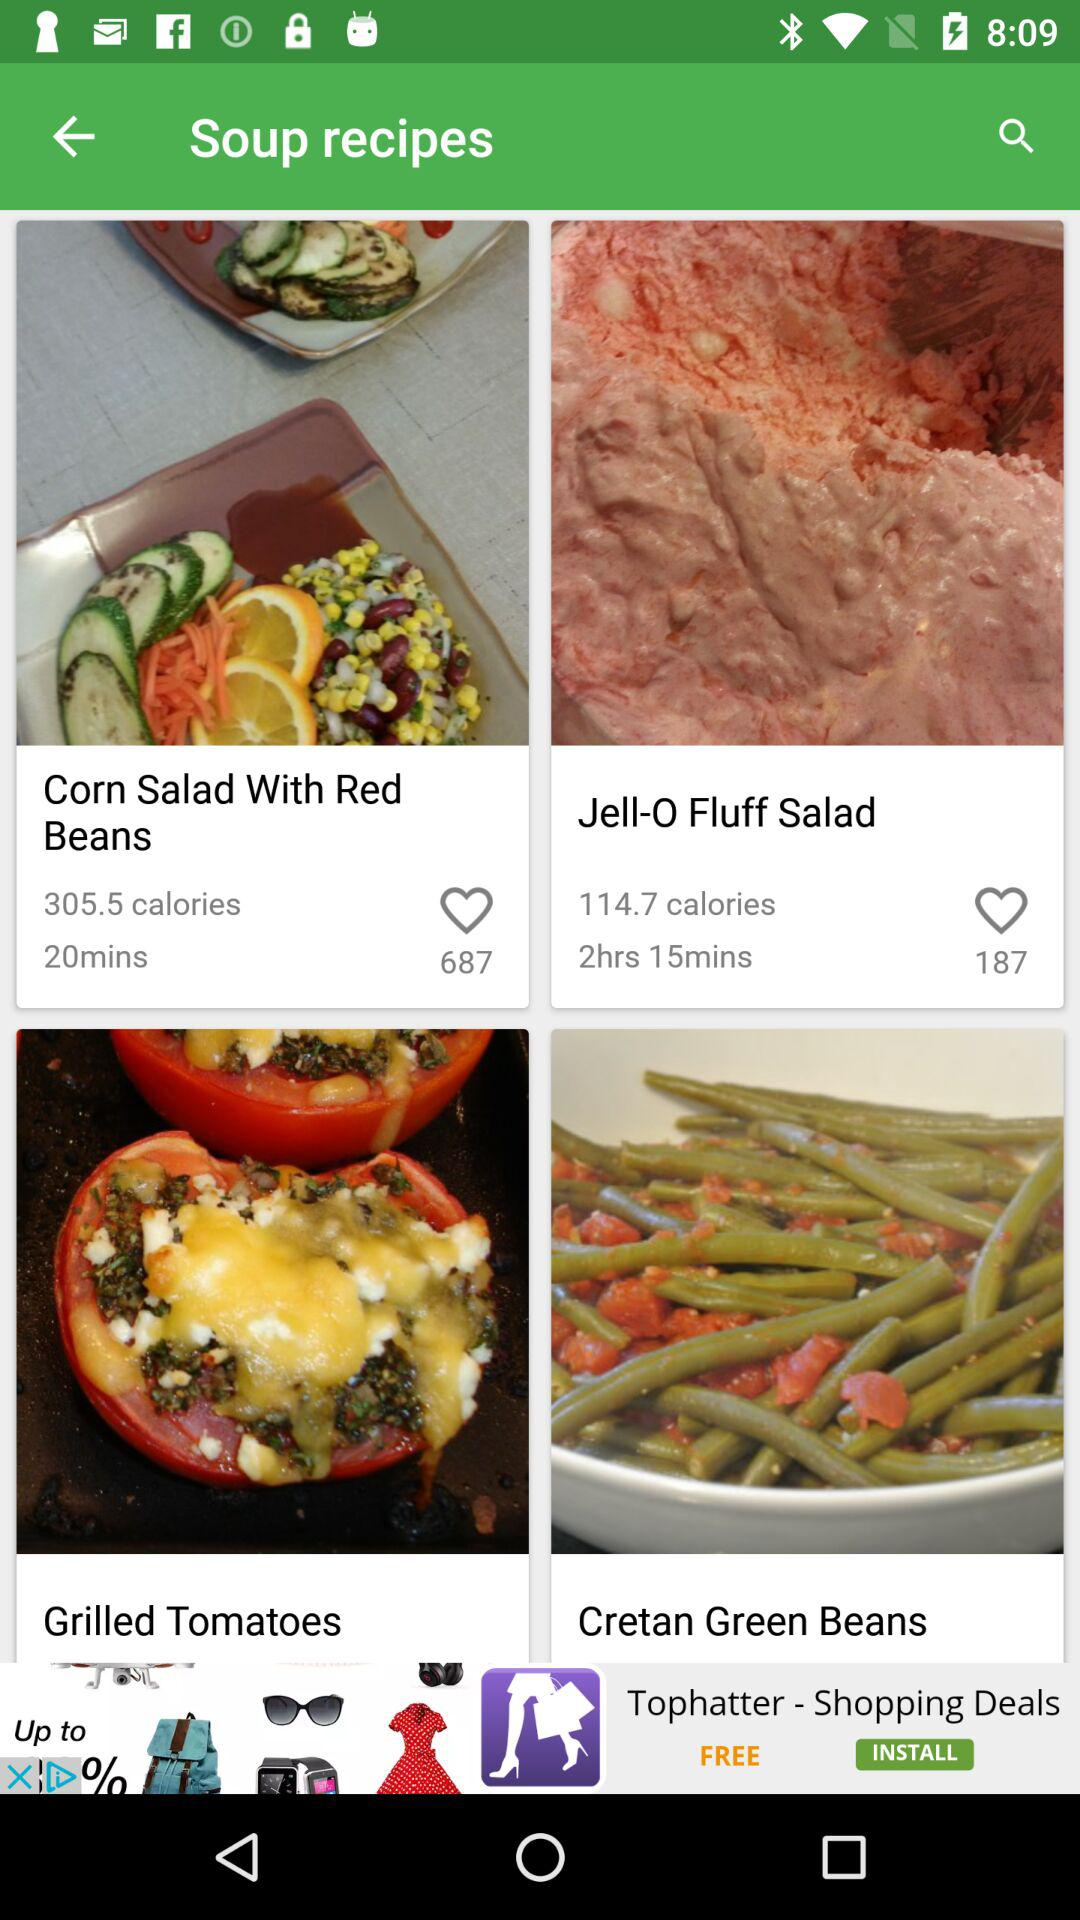How many calories does "Jell-O Fluff Salad" contain? It contains 114.7 calories. 